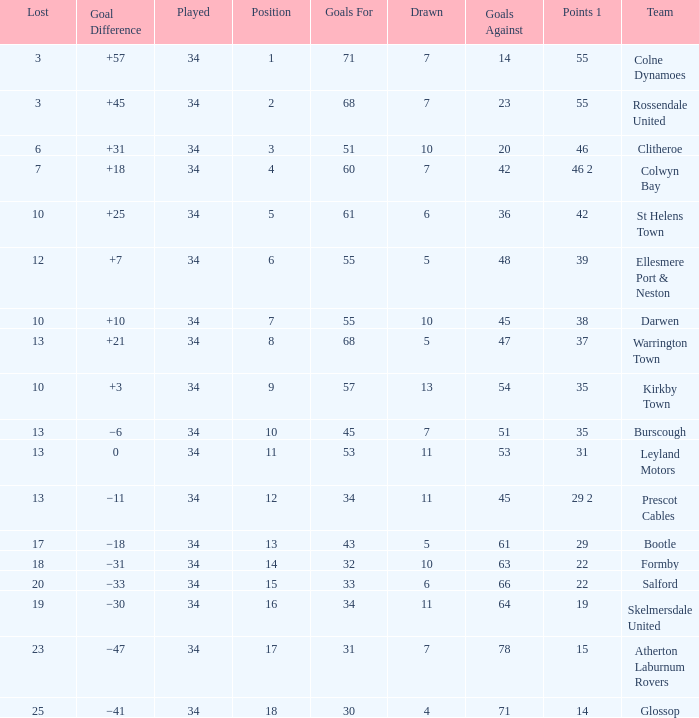How many Drawn have a Lost smaller than 25, and a Goal Difference of +7, and a Played larger than 34? 0.0. 